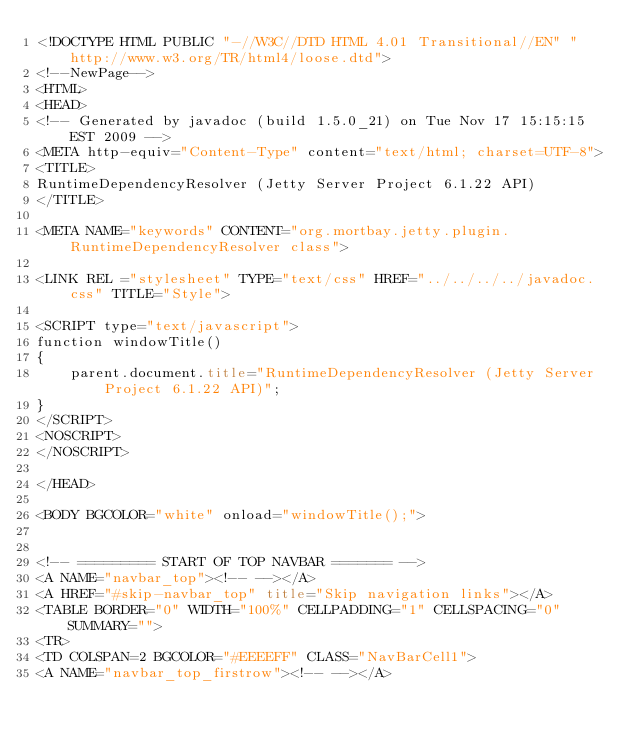<code> <loc_0><loc_0><loc_500><loc_500><_HTML_><!DOCTYPE HTML PUBLIC "-//W3C//DTD HTML 4.01 Transitional//EN" "http://www.w3.org/TR/html4/loose.dtd">
<!--NewPage-->
<HTML>
<HEAD>
<!-- Generated by javadoc (build 1.5.0_21) on Tue Nov 17 15:15:15 EST 2009 -->
<META http-equiv="Content-Type" content="text/html; charset=UTF-8">
<TITLE>
RuntimeDependencyResolver (Jetty Server Project 6.1.22 API)
</TITLE>

<META NAME="keywords" CONTENT="org.mortbay.jetty.plugin.RuntimeDependencyResolver class">

<LINK REL ="stylesheet" TYPE="text/css" HREF="../../../../javadoc.css" TITLE="Style">

<SCRIPT type="text/javascript">
function windowTitle()
{
    parent.document.title="RuntimeDependencyResolver (Jetty Server Project 6.1.22 API)";
}
</SCRIPT>
<NOSCRIPT>
</NOSCRIPT>

</HEAD>

<BODY BGCOLOR="white" onload="windowTitle();">


<!-- ========= START OF TOP NAVBAR ======= -->
<A NAME="navbar_top"><!-- --></A>
<A HREF="#skip-navbar_top" title="Skip navigation links"></A>
<TABLE BORDER="0" WIDTH="100%" CELLPADDING="1" CELLSPACING="0" SUMMARY="">
<TR>
<TD COLSPAN=2 BGCOLOR="#EEEEFF" CLASS="NavBarCell1">
<A NAME="navbar_top_firstrow"><!-- --></A></code> 